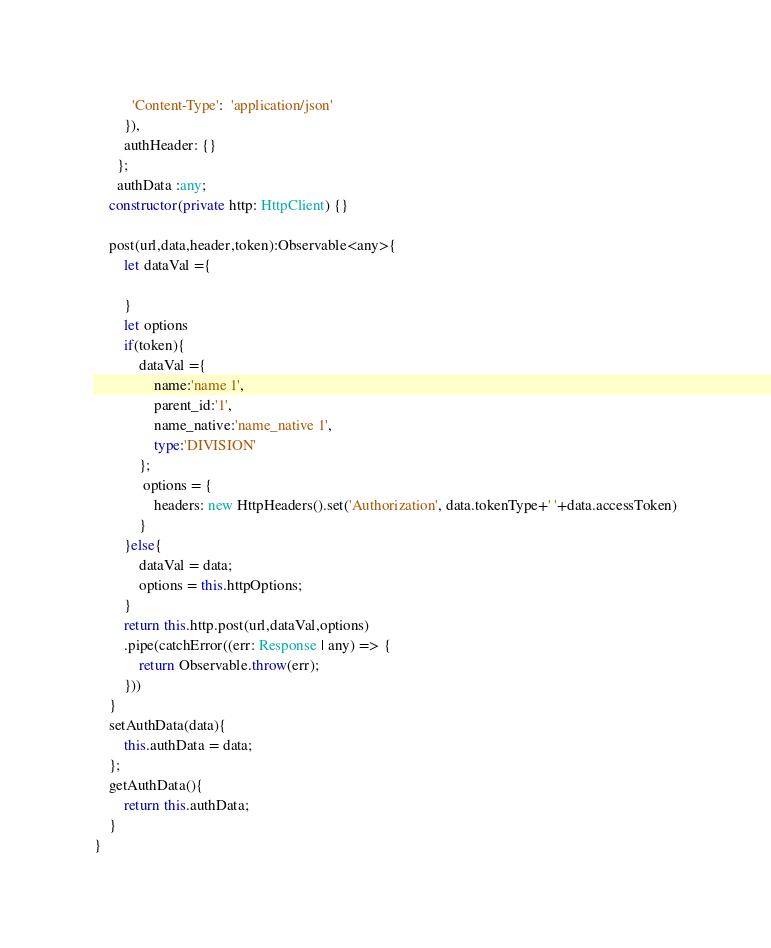<code> <loc_0><loc_0><loc_500><loc_500><_TypeScript_>          'Content-Type':  'application/json'
        }),
        authHeader: {}
      };
      authData :any;
    constructor(private http: HttpClient) {}

    post(url,data,header,token):Observable<any>{
        let dataVal ={

        }
        let options
        if(token){
            dataVal ={
                name:'name 1',
                parent_id:'1',
                name_native:'name_native 1',
                type:'DIVISION'
            };
             options = {
                headers: new HttpHeaders().set('Authorization', data.tokenType+' '+data.accessToken)
            } 
        }else{
            dataVal = data;
            options = this.httpOptions;
        }
        return this.http.post(url,dataVal,options)
        .pipe(catchError((err: Response | any) => {
            return Observable.throw(err);
        }))
    }
    setAuthData(data){
        this.authData = data;
    };
    getAuthData(){
        return this.authData;
    }
}</code> 